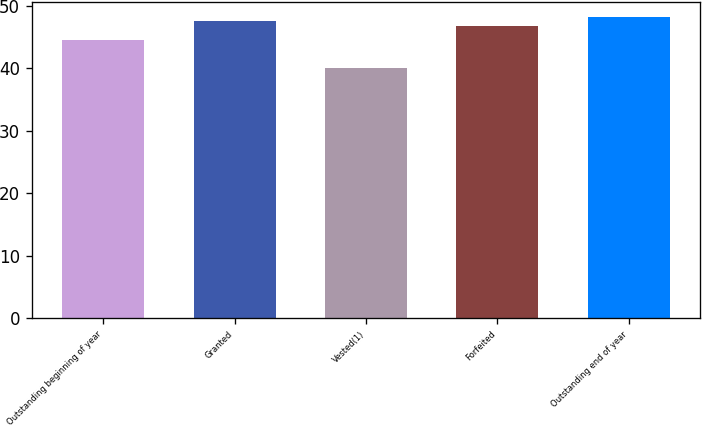Convert chart. <chart><loc_0><loc_0><loc_500><loc_500><bar_chart><fcel>Outstanding beginning of year<fcel>Granted<fcel>Vested(1)<fcel>Forfeited<fcel>Outstanding end of year<nl><fcel>44.45<fcel>47.46<fcel>39.94<fcel>46.72<fcel>48.2<nl></chart> 